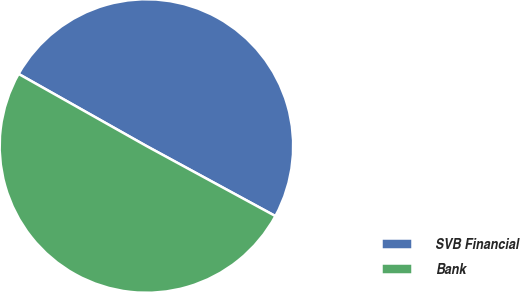Convert chart to OTSL. <chart><loc_0><loc_0><loc_500><loc_500><pie_chart><fcel>SVB Financial<fcel>Bank<nl><fcel>49.75%<fcel>50.25%<nl></chart> 